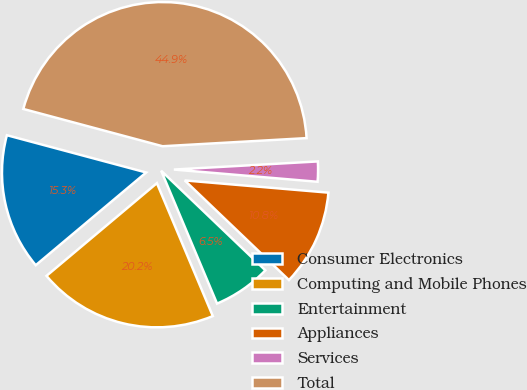<chart> <loc_0><loc_0><loc_500><loc_500><pie_chart><fcel>Consumer Electronics<fcel>Computing and Mobile Phones<fcel>Entertainment<fcel>Appliances<fcel>Services<fcel>Total<nl><fcel>15.28%<fcel>20.22%<fcel>6.52%<fcel>10.79%<fcel>2.25%<fcel>44.94%<nl></chart> 